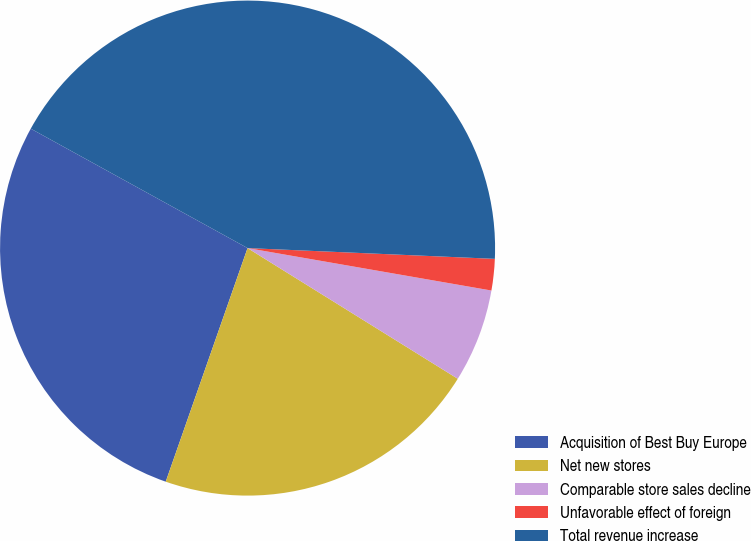<chart> <loc_0><loc_0><loc_500><loc_500><pie_chart><fcel>Acquisition of Best Buy Europe<fcel>Net new stores<fcel>Comparable store sales decline<fcel>Unfavorable effect of foreign<fcel>Total revenue increase<nl><fcel>27.65%<fcel>21.51%<fcel>6.11%<fcel>2.05%<fcel>42.68%<nl></chart> 